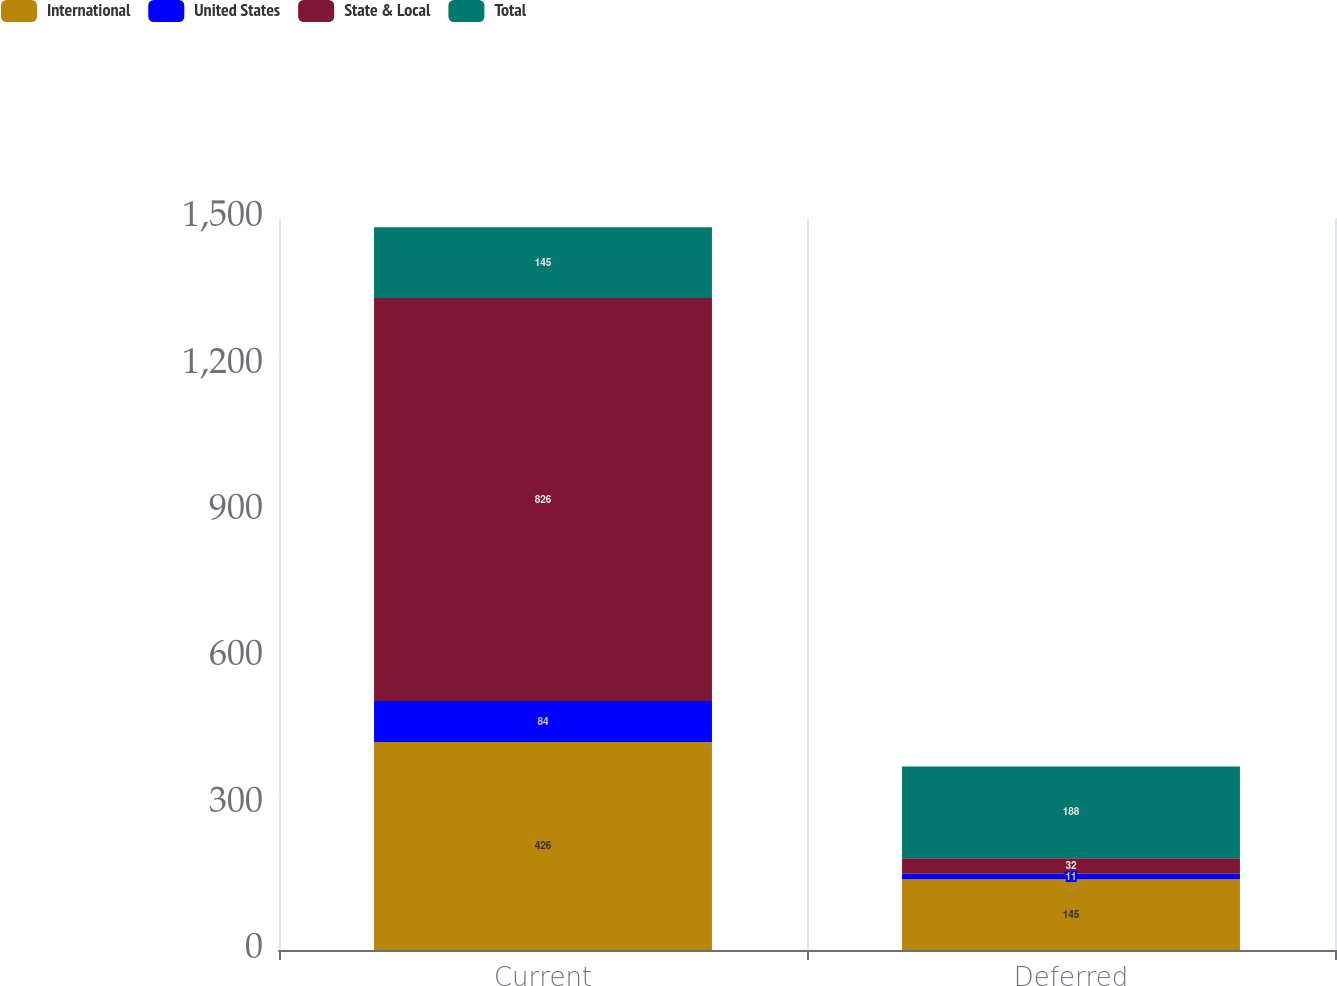Convert chart. <chart><loc_0><loc_0><loc_500><loc_500><stacked_bar_chart><ecel><fcel>Current<fcel>Deferred<nl><fcel>International<fcel>426<fcel>145<nl><fcel>United States<fcel>84<fcel>11<nl><fcel>State & Local<fcel>826<fcel>32<nl><fcel>Total<fcel>145<fcel>188<nl></chart> 